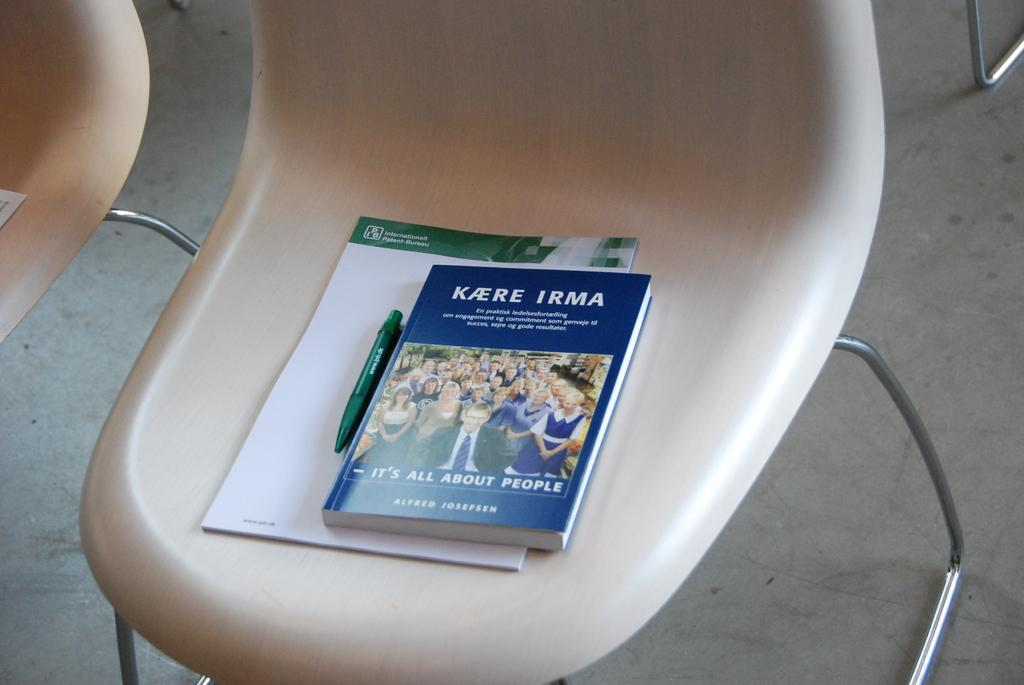<image>
Offer a succinct explanation of the picture presented. white plastic chair whit kaere irma booklets and a pen 